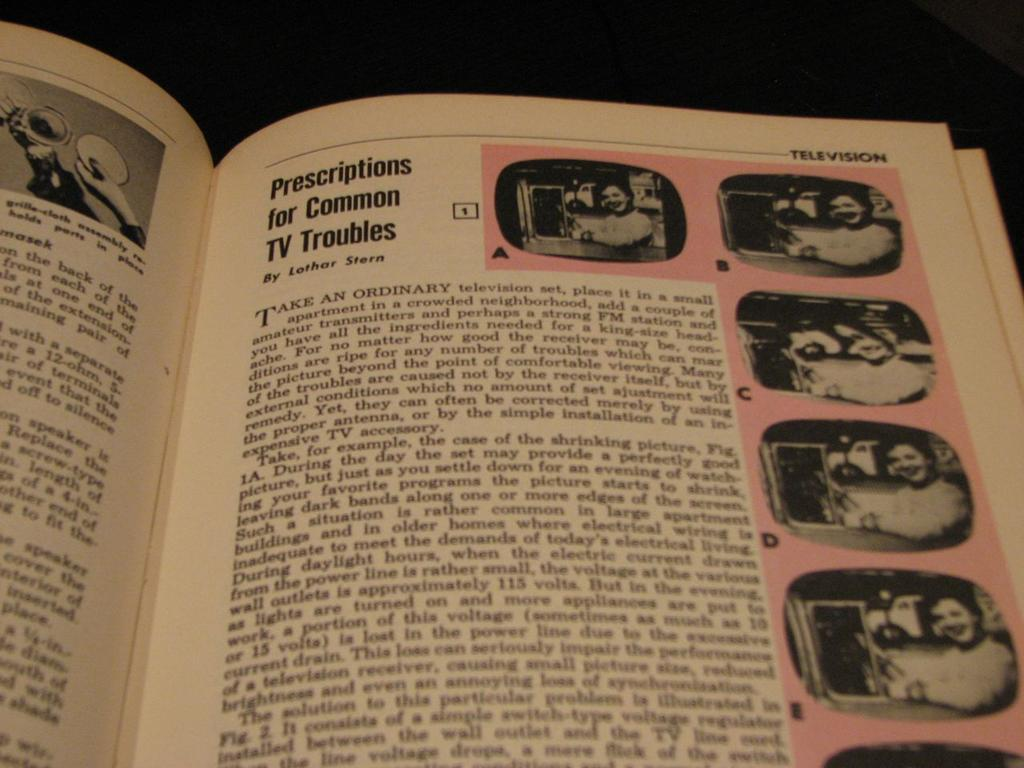<image>
Describe the image concisely. A book open on the section television  with the head title  prescriptions for common TV troubles. 